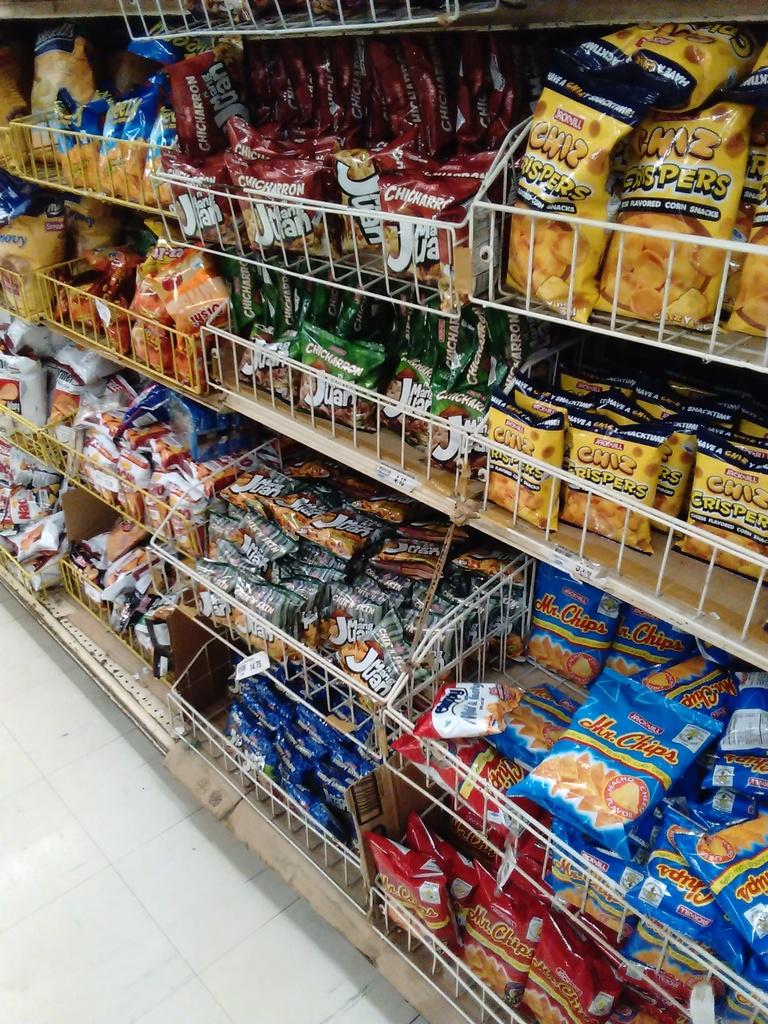What does it say on the blue bag after mr.?
Provide a succinct answer. Chips. 